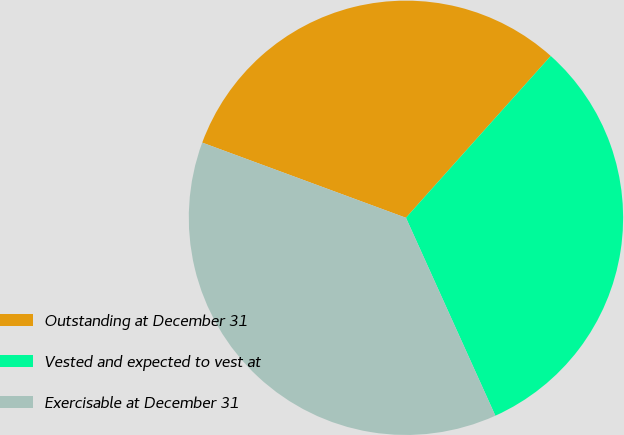<chart> <loc_0><loc_0><loc_500><loc_500><pie_chart><fcel>Outstanding at December 31<fcel>Vested and expected to vest at<fcel>Exercisable at December 31<nl><fcel>30.99%<fcel>31.63%<fcel>37.38%<nl></chart> 